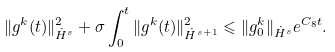Convert formula to latex. <formula><loc_0><loc_0><loc_500><loc_500>\| g ^ { k } ( t ) \| ^ { 2 } _ { \dot { H } ^ { s } } + \sigma \int _ { 0 } ^ { t } \| g ^ { k } ( t ) \| ^ { 2 } _ { \dot { H } ^ { s + 1 } } \leqslant \| g ^ { k } _ { 0 } \| _ { \dot { H } ^ { s } } e ^ { C _ { 8 } t } .</formula> 